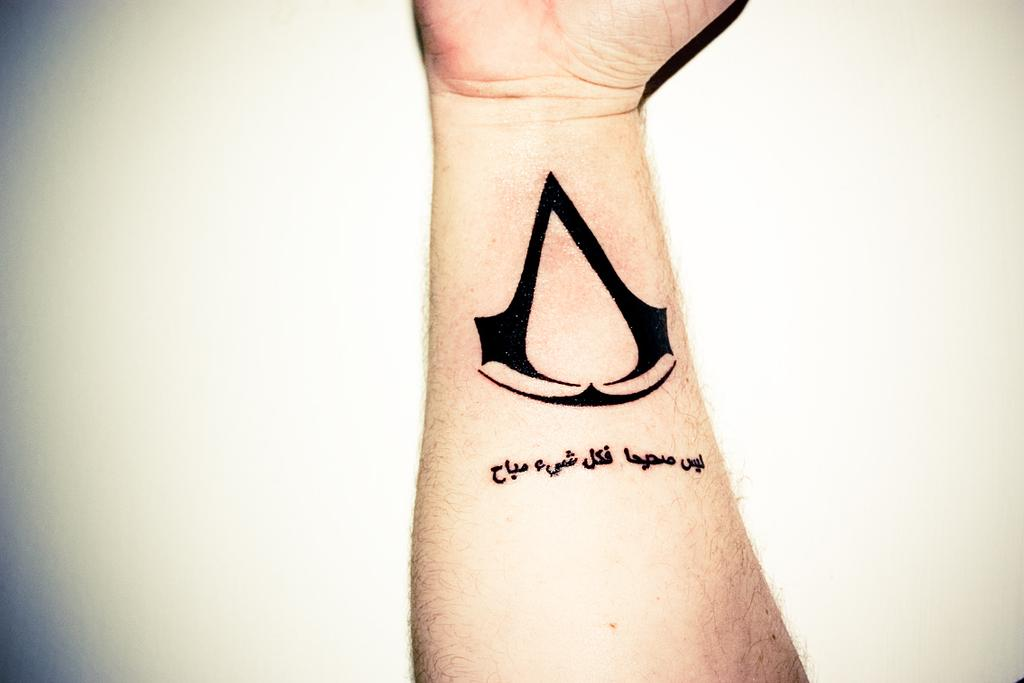What is visible on the hand in the image? There is a tattoo on a hand in the image. What color is the background of the image? The background of the image is white. What type of food is being pushed by the tattooed hand in the image? There is no food or pushing action present in the image; it only features a tattoo on a hand against a white background. 